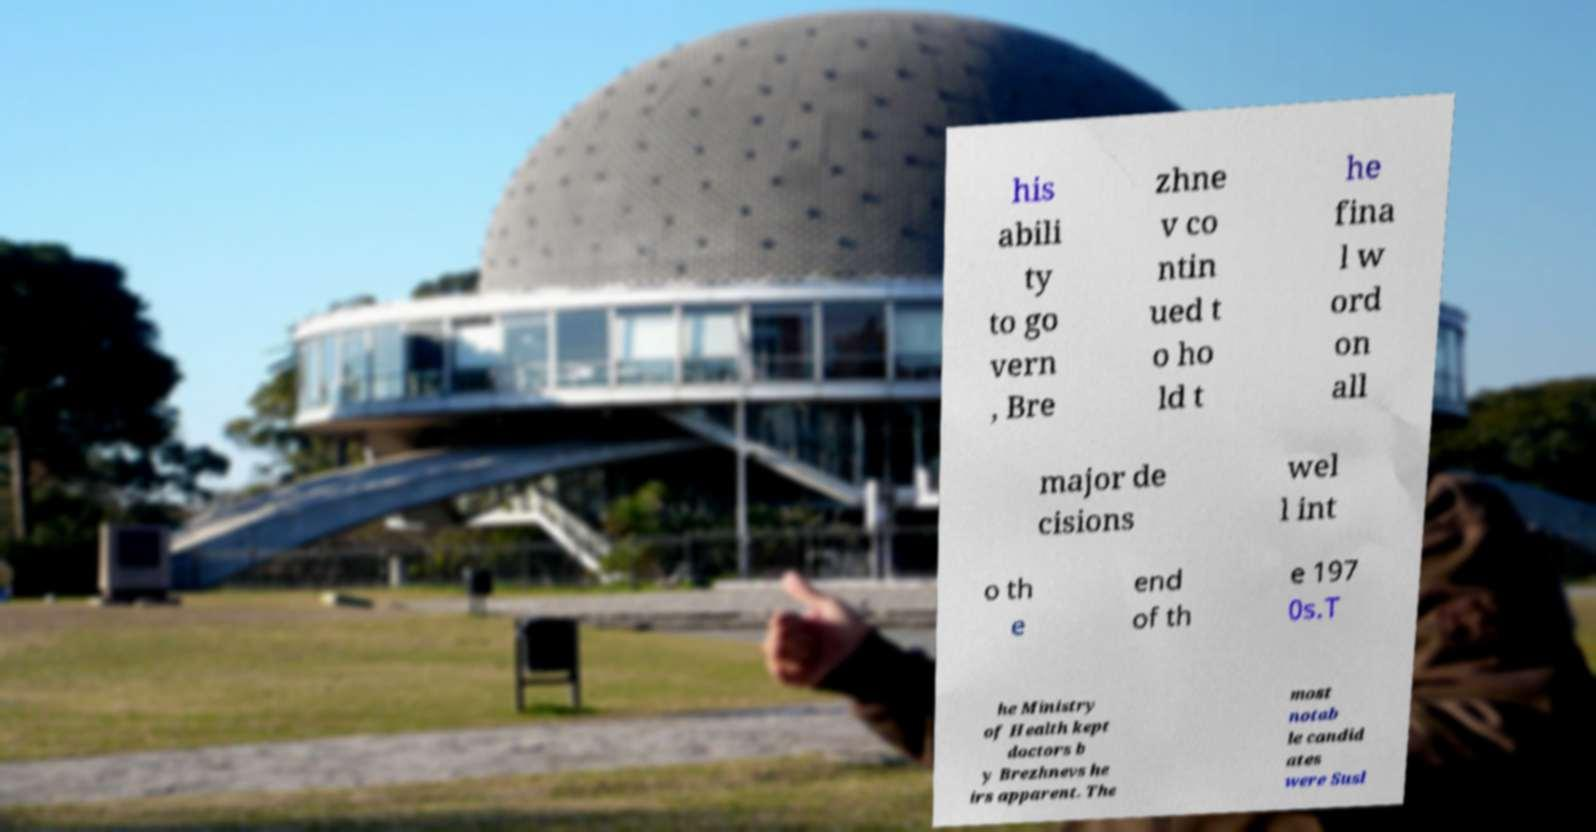Could you assist in decoding the text presented in this image and type it out clearly? his abili ty to go vern , Bre zhne v co ntin ued t o ho ld t he fina l w ord on all major de cisions wel l int o th e end of th e 197 0s.T he Ministry of Health kept doctors b y Brezhnevs he irs apparent. The most notab le candid ates were Susl 